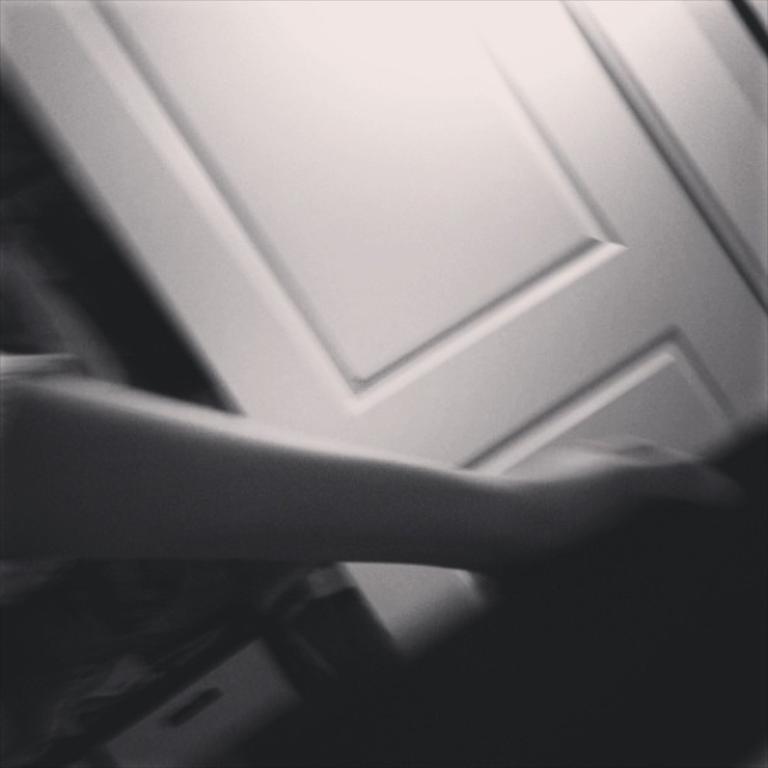Can you describe this image briefly? In this image we can see one white door, one person hand holding one object and some different objects are on the surface. 